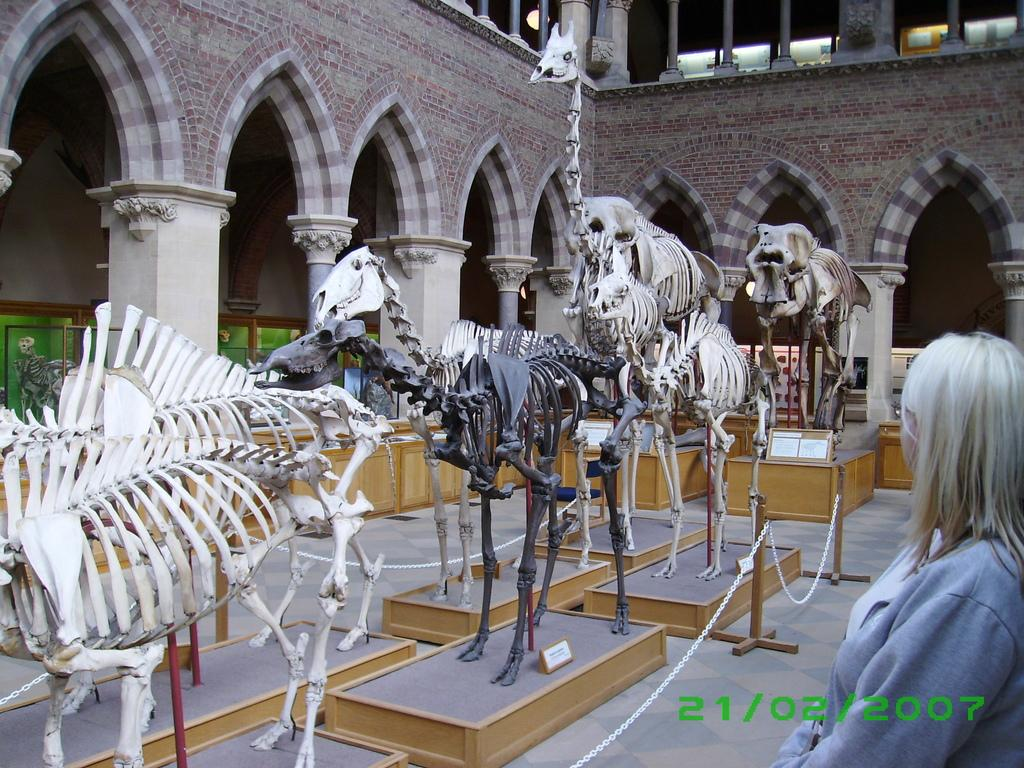What can be seen on the wooden surface in the image? There are skeletons of animals on a wooden surface. What is connected to the pole in the image? There is a chain attached to a pole. Where is the woman located in the image? The woman is inside a building. What type of bath can be seen in the image? There is no bath present in the image. What kind of play is the woman engaged in with the skeletons? The image does not show the woman interacting with the skeletons, so it cannot be determined if she is playing with them. 